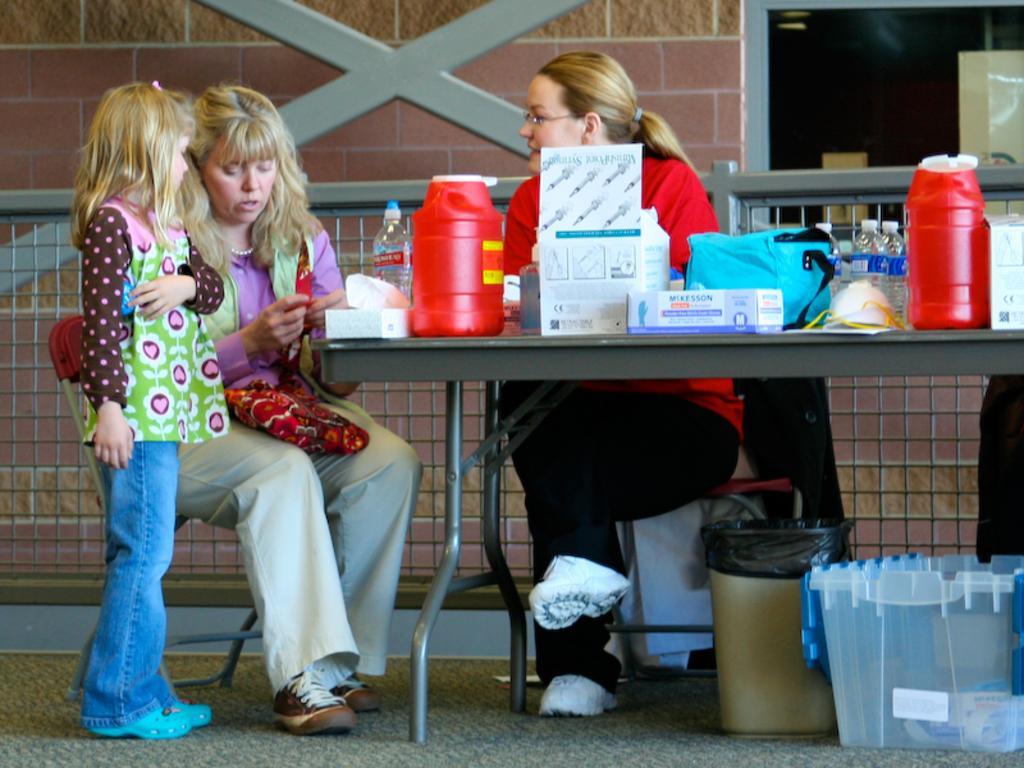In one or two sentences, can you explain what this image depicts? A woman is sitting at a table with some medicines and other articles. Another woman approached her with a girl. 